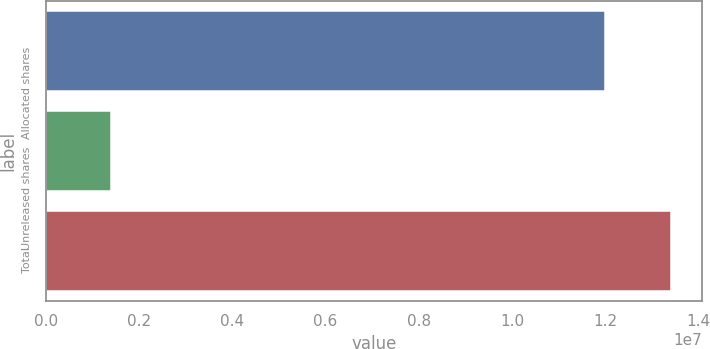<chart> <loc_0><loc_0><loc_500><loc_500><bar_chart><fcel>Allocated shares<fcel>Unreleased shares<fcel>Total<nl><fcel>1.19964e+07<fcel>1.40395e+06<fcel>1.34003e+07<nl></chart> 